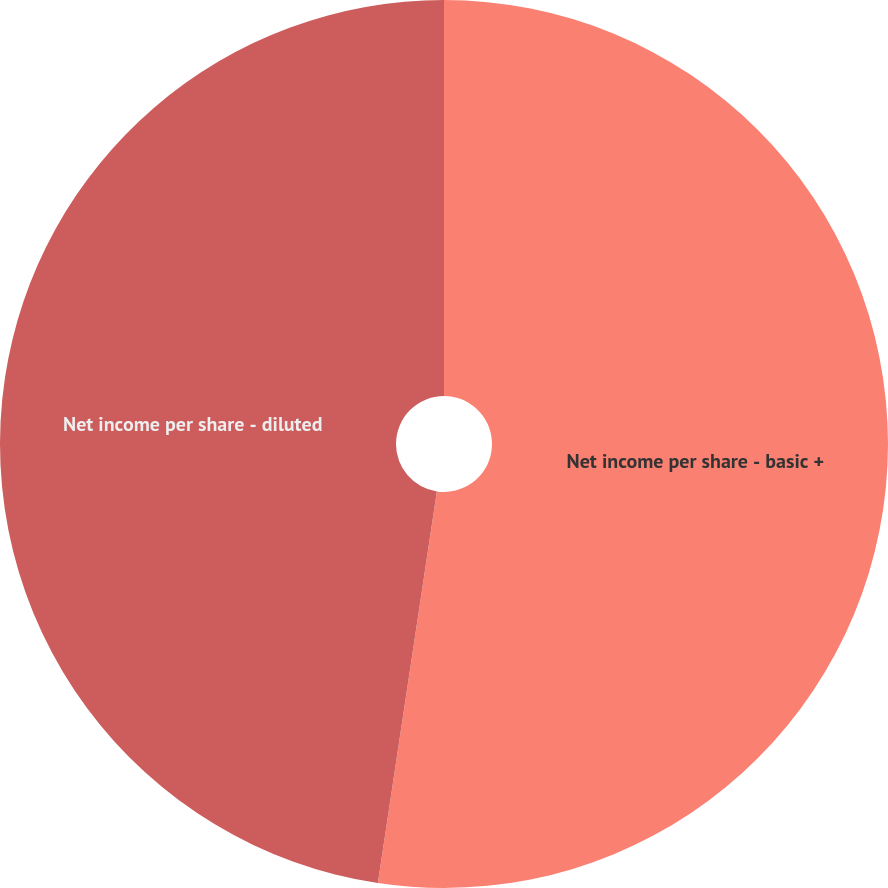<chart> <loc_0><loc_0><loc_500><loc_500><pie_chart><fcel>Net income per share - basic +<fcel>Net income per share - diluted<nl><fcel>52.38%<fcel>47.62%<nl></chart> 